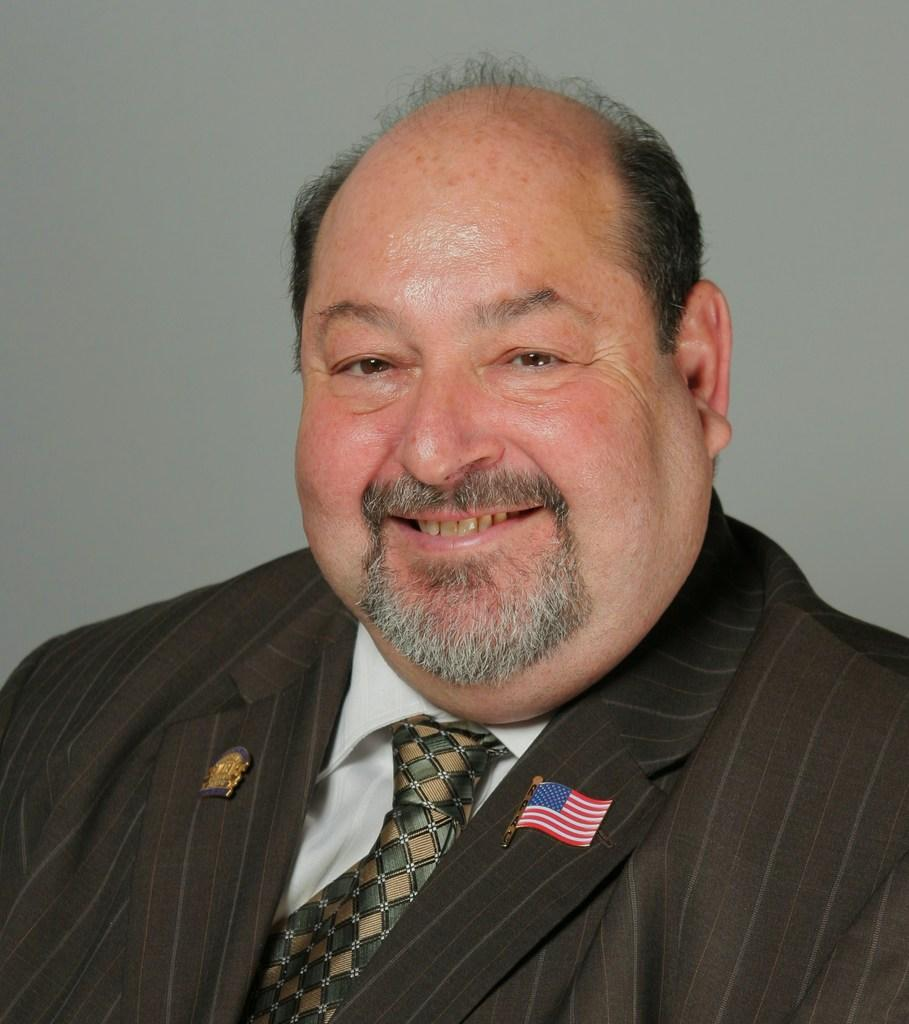Who or what is the main subject in the image? There is a person in the image. What is the facial expression of the person? The person has a smile on their face. What is the color of the background in the image? There is a white color background in the image. What is the person wearing on their coat? The person is wearing a coat with a flag on it. How many steps does the person take in the image? There is no indication of the person taking any steps in the image; they are standing still. What type of honey is being used by the person in the image? There is no honey present in the image, and the person is not using any honey. 